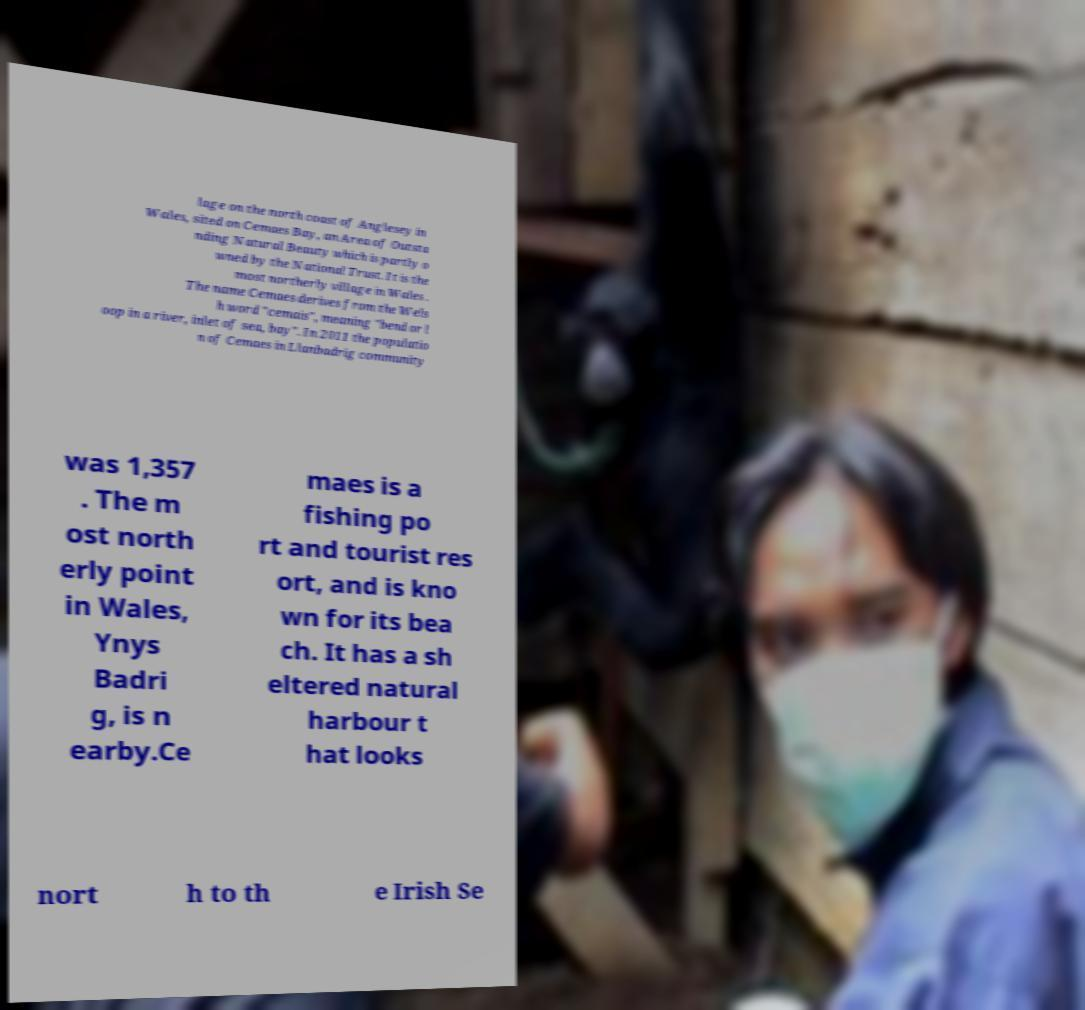There's text embedded in this image that I need extracted. Can you transcribe it verbatim? lage on the north coast of Anglesey in Wales, sited on Cemaes Bay, an Area of Outsta nding Natural Beauty which is partly o wned by the National Trust. It is the most northerly village in Wales . The name Cemaes derives from the Wels h word "cemais", meaning "bend or l oop in a river, inlet of sea, bay". In 2011 the populatio n of Cemaes in Llanbadrig community was 1,357 . The m ost north erly point in Wales, Ynys Badri g, is n earby.Ce maes is a fishing po rt and tourist res ort, and is kno wn for its bea ch. It has a sh eltered natural harbour t hat looks nort h to th e Irish Se 